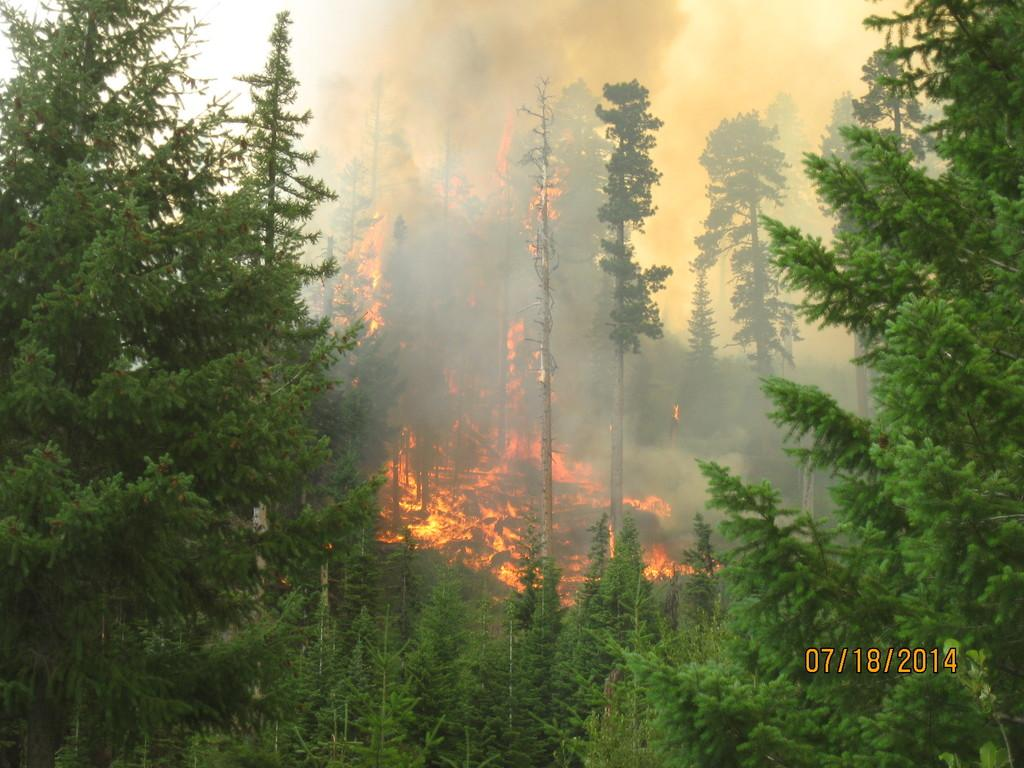What type of landscape is shown in the image? The image depicts a view of a forest. What is happening in the center of the forest? There is a fire in the center of the forest. What is the result of the fire in the image? Smoke is present due to the fire. What type of trees can be seen in the front bottom side of the image? Green trees are visible in the front bottom side of the image. What color is the vein visible on the tree in the image? There is no vein visible on a tree in the image. How does the forest look during winter in the image? The image does not depict the forest during winter; it shows a forest with a fire and green trees. 